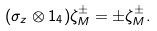Convert formula to latex. <formula><loc_0><loc_0><loc_500><loc_500>( \sigma _ { z } \otimes { 1 } _ { 4 } ) \zeta ^ { \pm } _ { M } = \pm \zeta ^ { \pm } _ { M } .</formula> 